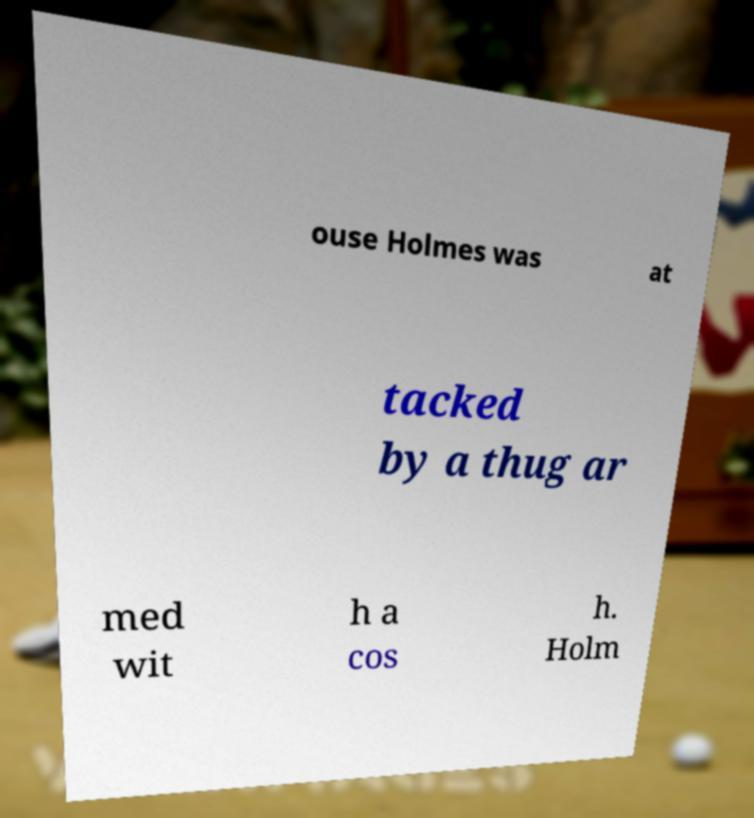Could you assist in decoding the text presented in this image and type it out clearly? ouse Holmes was at tacked by a thug ar med wit h a cos h. Holm 